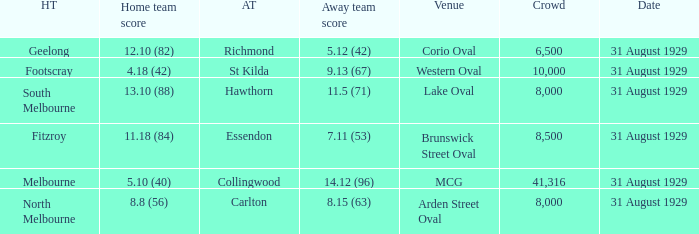What date was the game when the away team was carlton? 31 August 1929. 